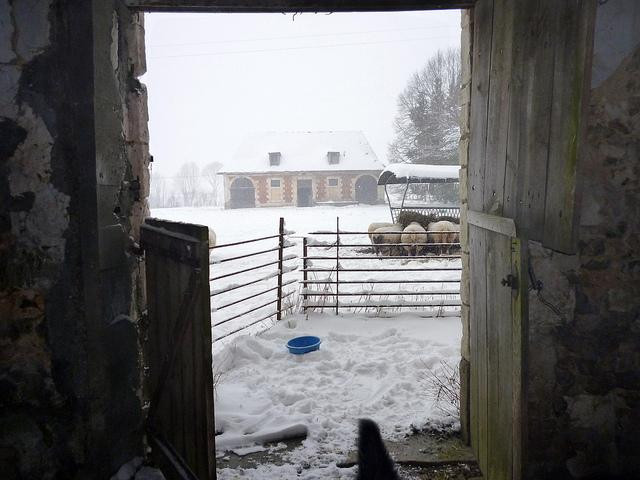From what kind of building was this picture taken? barn 